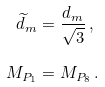Convert formula to latex. <formula><loc_0><loc_0><loc_500><loc_500>\widetilde { d } _ { m } & = \frac { d _ { m } } { \sqrt { 3 } } \, , \\ \quad M _ { P _ { 1 } } & = M _ { P _ { 8 } } \, .</formula> 